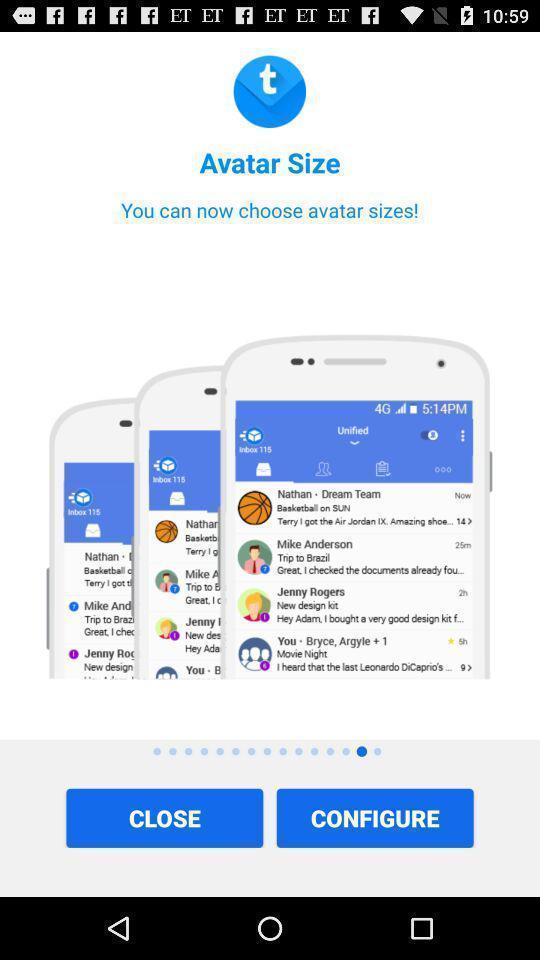Explain the elements present in this screenshot. Screen showing welcome page. 